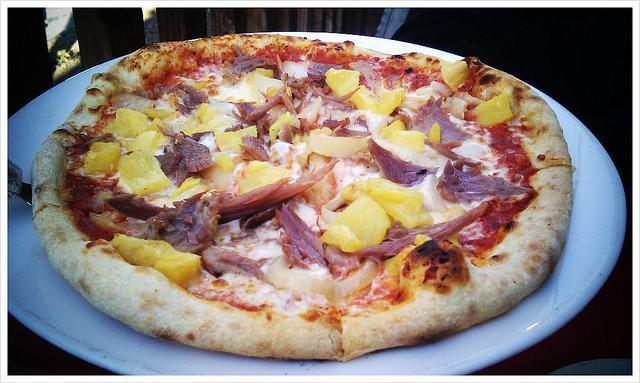How many different toppings are easily found?
Give a very brief answer. 2. 